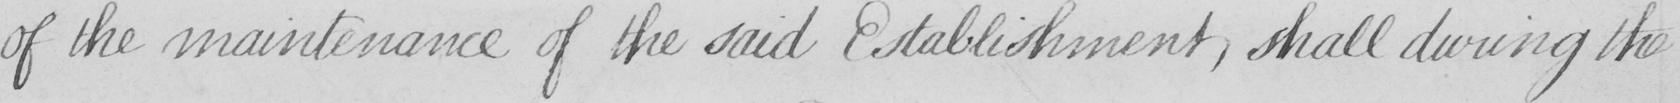Please transcribe the handwritten text in this image. of the maintenance of the said Establishment , shall during the 